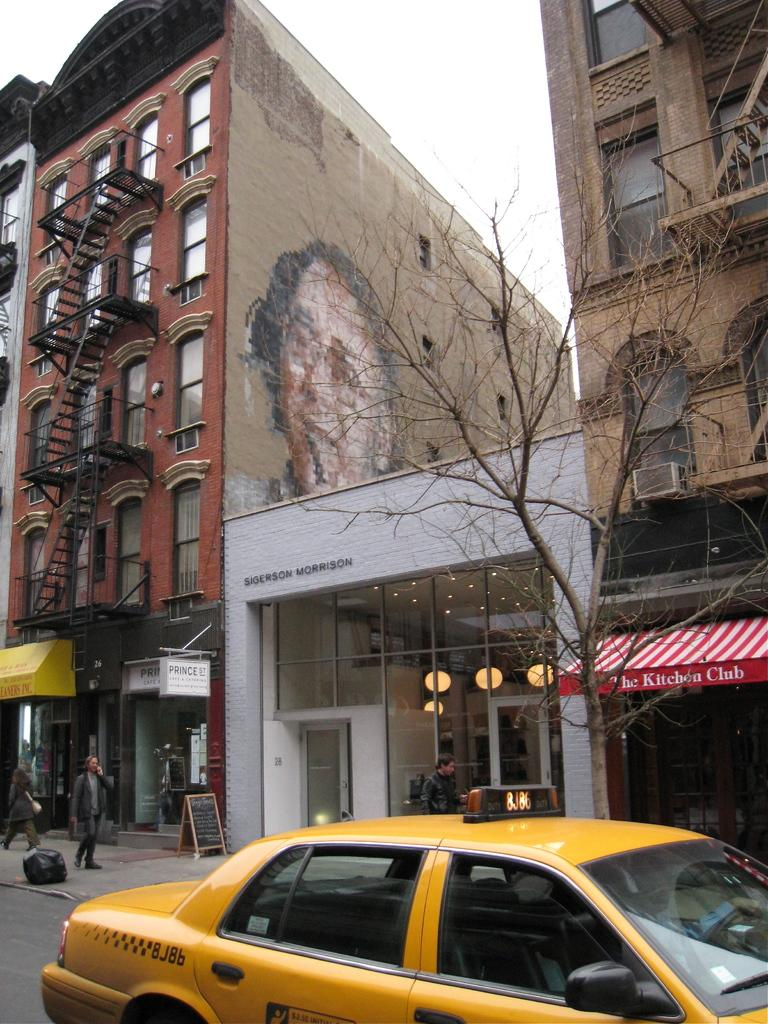<image>
Write a terse but informative summary of the picture. A yellow taxi is driving past a building that says The Kitchen Club. 